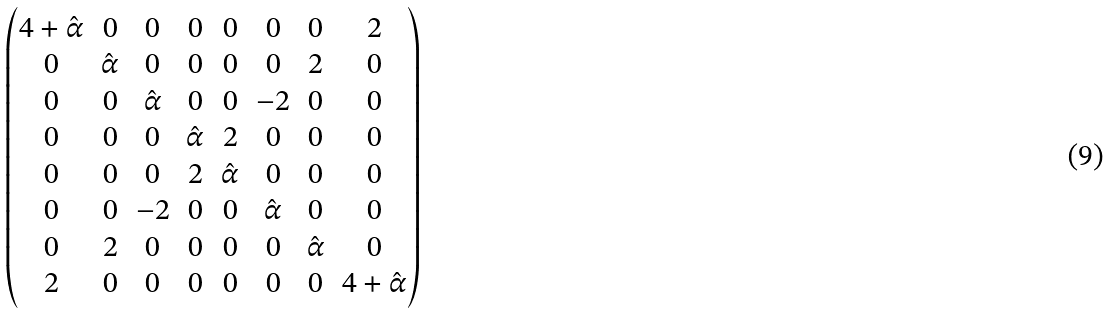Convert formula to latex. <formula><loc_0><loc_0><loc_500><loc_500>\begin{pmatrix} 4 + \hat { \alpha } & 0 & 0 & 0 & 0 & 0 & 0 & 2 \\ 0 & \hat { \alpha } & 0 & 0 & 0 & 0 & 2 & 0 \\ 0 & 0 & \hat { \alpha } & 0 & 0 & - 2 & 0 & 0 \\ 0 & 0 & 0 & \hat { \alpha } & 2 & 0 & 0 & 0 \\ 0 & 0 & 0 & 2 & \hat { \alpha } & 0 & 0 & 0 \\ 0 & 0 & - 2 & 0 & 0 & \hat { \alpha } & 0 & 0 \\ 0 & 2 & 0 & 0 & 0 & 0 & \hat { \alpha } & 0 \\ 2 & 0 & 0 & 0 & 0 & 0 & 0 & 4 + \hat { \alpha } \end{pmatrix}</formula> 